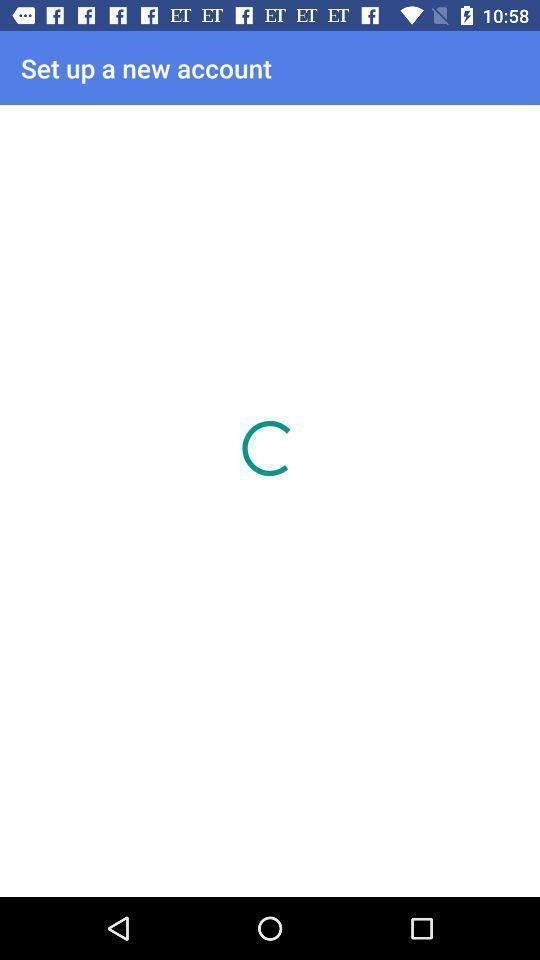Provide a description of this screenshot. Screen displaying the loading page to create an account. 